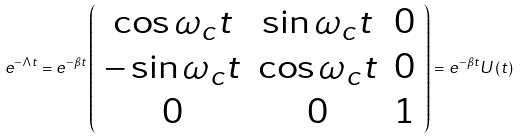Convert formula to latex. <formula><loc_0><loc_0><loc_500><loc_500>e ^ { - \Lambda t } = e ^ { - \beta t } \left ( \begin{array} { c c c } \cos \omega _ { c } t & \sin \omega _ { c } t & 0 \\ - \sin \omega _ { c } t & \cos \omega _ { c } t & 0 \\ 0 & 0 & 1 \end{array} \right ) = e ^ { - \beta t } U \left ( t \right )</formula> 